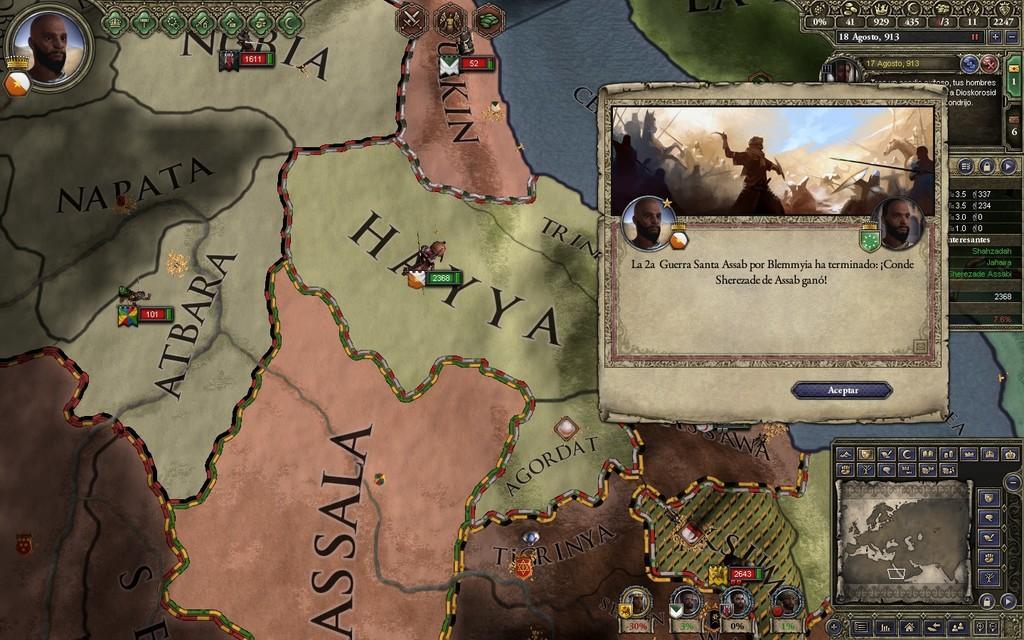Please provide a concise description of this image. This is the picture of a map which has some other pictures on it. 